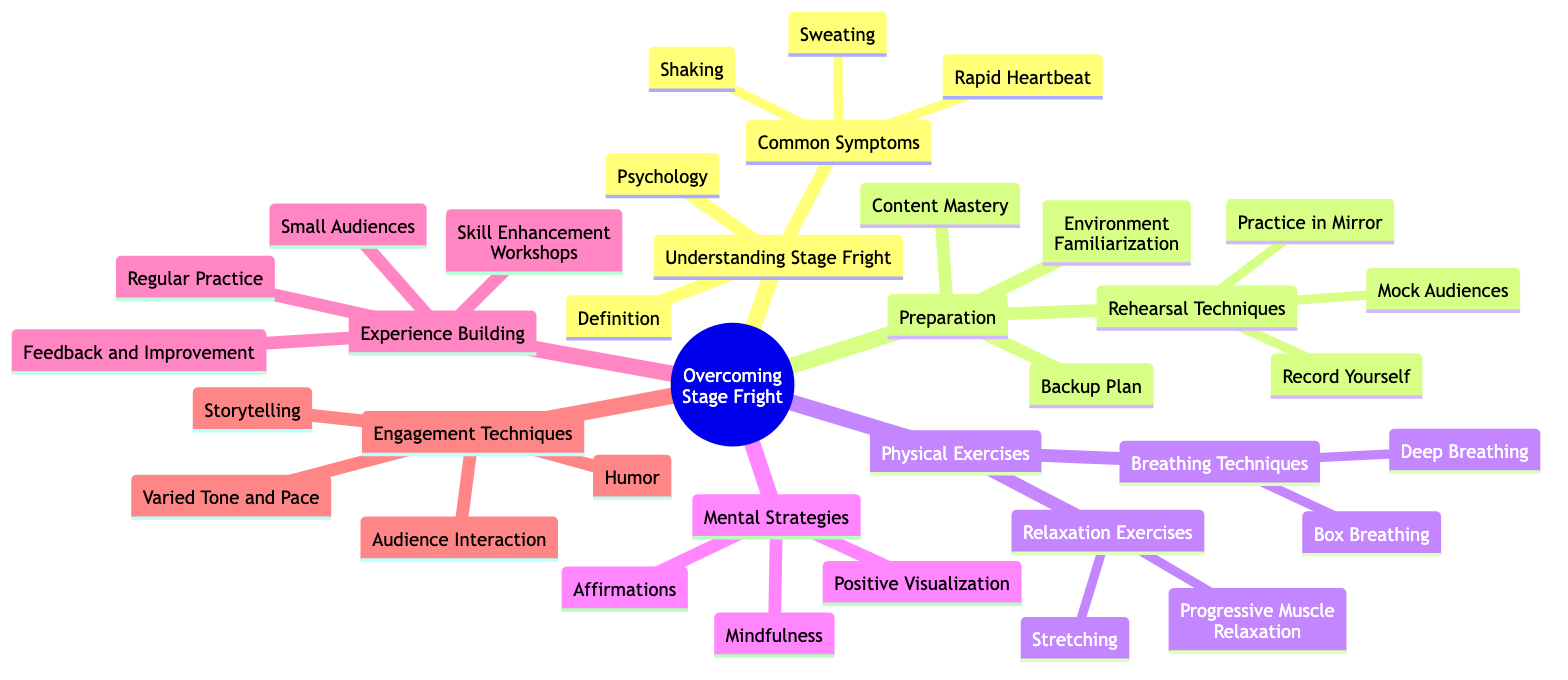What are the three areas of focus under "Understanding Stage Fright"? The diagram lists three specific nodes under "Understanding Stage Fright": "Definition", "Psychology", and "Common Symptoms".
Answer: Definition, Psychology, Common Symptoms How many techniques are listed under "Preparation"? The diagram shows four techniques under "Preparation": "Content Mastery", "Rehearsal Techniques", "Environment Familiarization", and "Backup Plan". This totals to four techniques.
Answer: 4 What are the two types of exercises included in "Physical Exercises"? The diagram specifies two main categories under "Physical Exercises": "Breathing Techniques" and "Relaxation Exercises".
Answer: Breathing Techniques, Relaxation Exercises What is one of the mental strategies noted for overcoming stage fright? "Positive Visualization" is one of the mental strategies listed in the diagram for overcoming stage fright.
Answer: Positive Visualization What type of exercise is described as "Inhale Deeply Through Nose, Exhale Slowly Through Mouth"? This description corresponds to "Deep Breathing", which is a specific breathing technique under "Breathing Techniques".
Answer: Deep Breathing How many total nodes are included under "Engagement Techniques"? Under "Engagement Techniques", there are four nodes: "Audience Interaction", "Storytelling", "Humor", and "Varied Tone and Pace". Therefore, there are four total nodes.
Answer: 4 What is a recommended strategy for gaining experience according to the diagram? The diagram suggests "Small Audiences" as one of the strategies under "Experience Building" for gaining confidence and practice.
Answer: Small Audiences Which breathing technique involves holding for equal counts? The "Box Breathing" technique is described in the diagram as involving inhaling, holding, exhaling, and holding for equal counts.
Answer: Box Breathing 